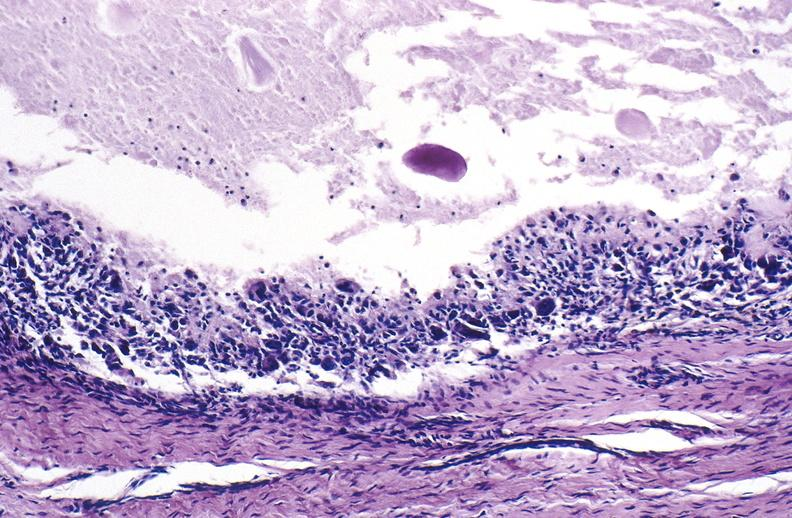s excellent gangrenous necrosis of fingers present?
Answer the question using a single word or phrase. No 